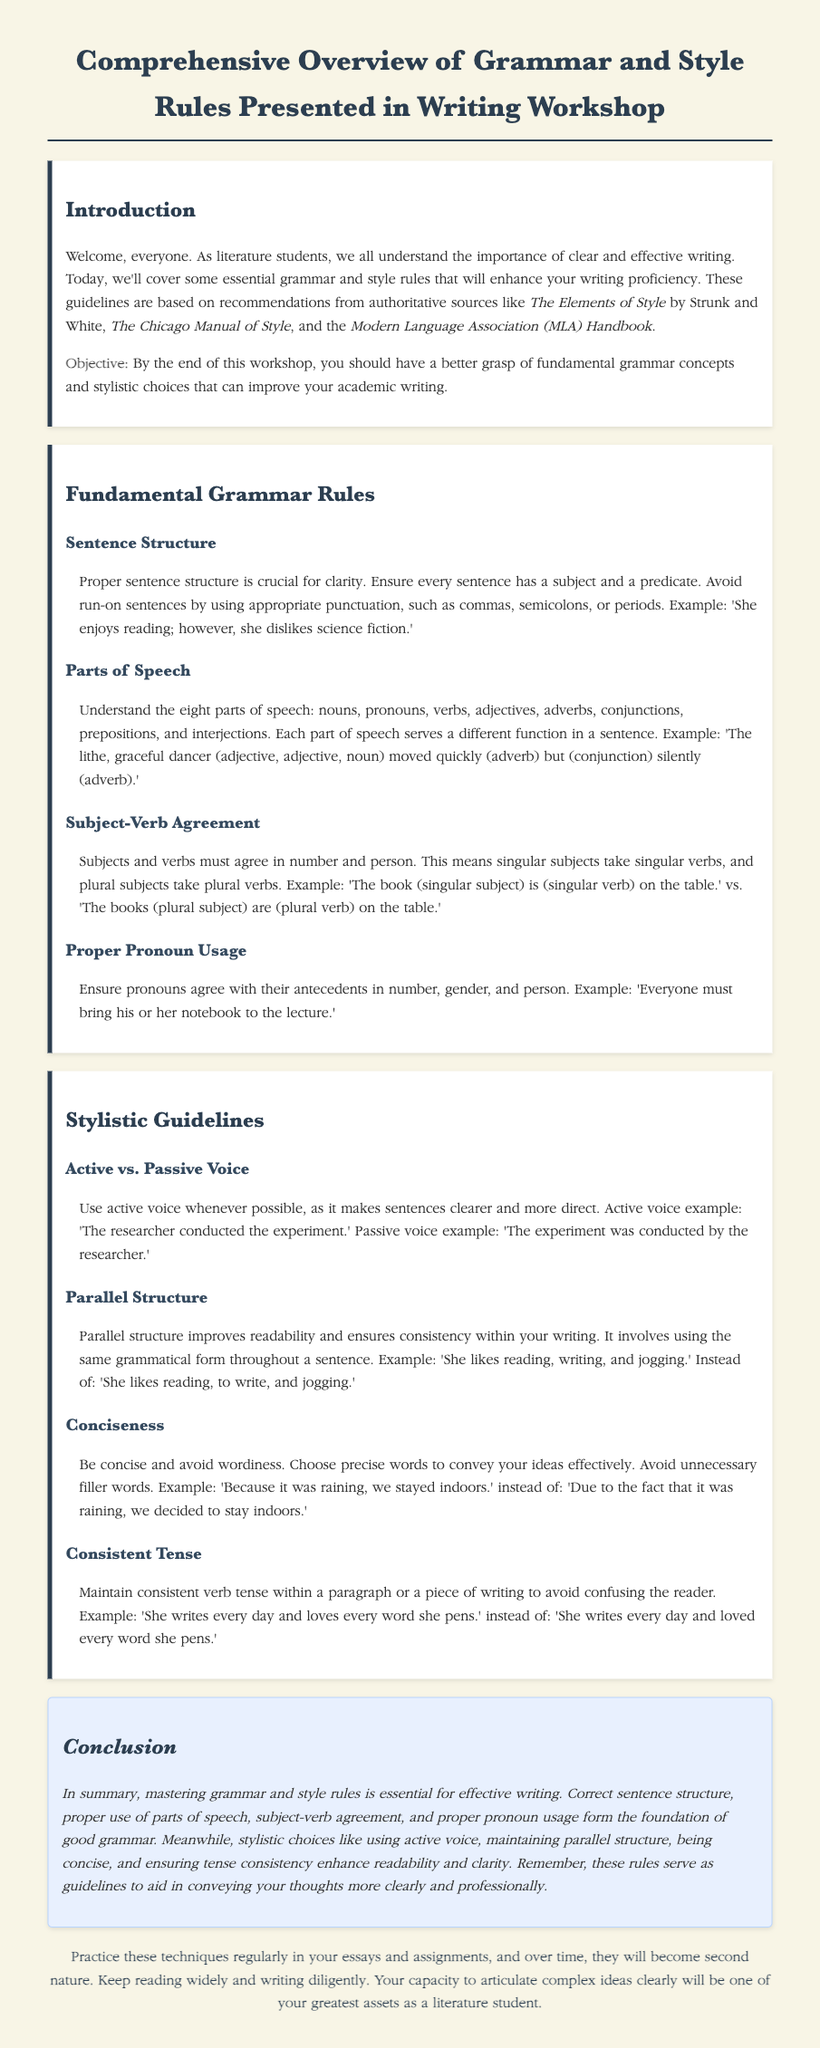What is the title of the workshop? The title of the workshop is presented at the top of the document.
Answer: Comprehensive Overview of Grammar and Style Rules Presented in Writing Workshop What is the objective of the workshop? The objective of the workshop is stated clearly in the introduction.
Answer: Better grasp of fundamental grammar concepts and stylistic choices How many parts of speech are mentioned? The document specifies eight parts of speech under the grammar rules section.
Answer: Eight What is an example of proper pronoun usage given in the document? The document provides a specific example under the proper pronoun usage section.
Answer: Everyone must bring his or her notebook to the lecture Which voice is preferred in writing according to the workshop? The document emphasizes the importance of using one voice over another.
Answer: Active voice What is the suggested structure for a list according to parallel structure guidelines? The document gives an example of how to maintain parallel structure in lists.
Answer: She likes reading, writing, and jogging What does the document say about maintaining verb tense? The document includes a section discussing consistency in verb tense within writing.
Answer: Maintain consistent verb tense What type of students is the workshop aimed at? The introduction identifies a specific group that would benefit from the workshop.
Answer: Literature students What is included in the conclusion section of the document? The conclusion summarizes the main themes addressed throughout the workshop.
Answer: Mastering grammar and style rules is essential for effective writing 